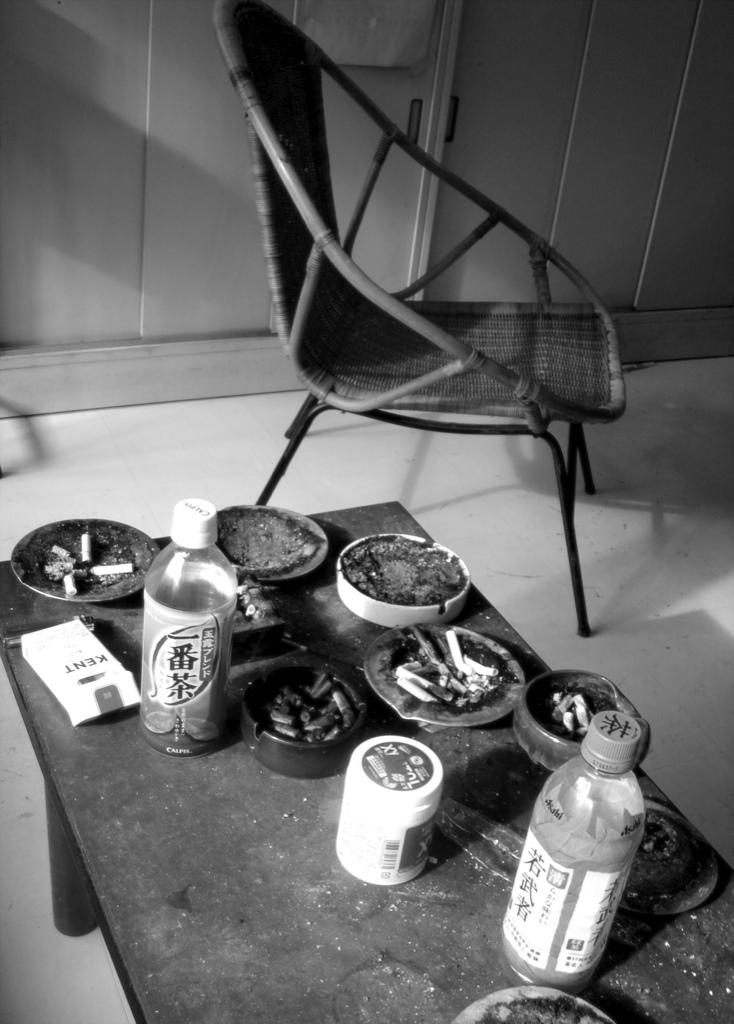What type of furniture is located behind the table in the image? There is a chair behind the table in the image. What items can be seen on the table? The table contains bottles and hash trays. What type of wrist support is visible on the table in the image? There is no wrist support present in the image. What type of corn is being served in the lunchroom in the image? There is no corn or lunchroom present in the image. 